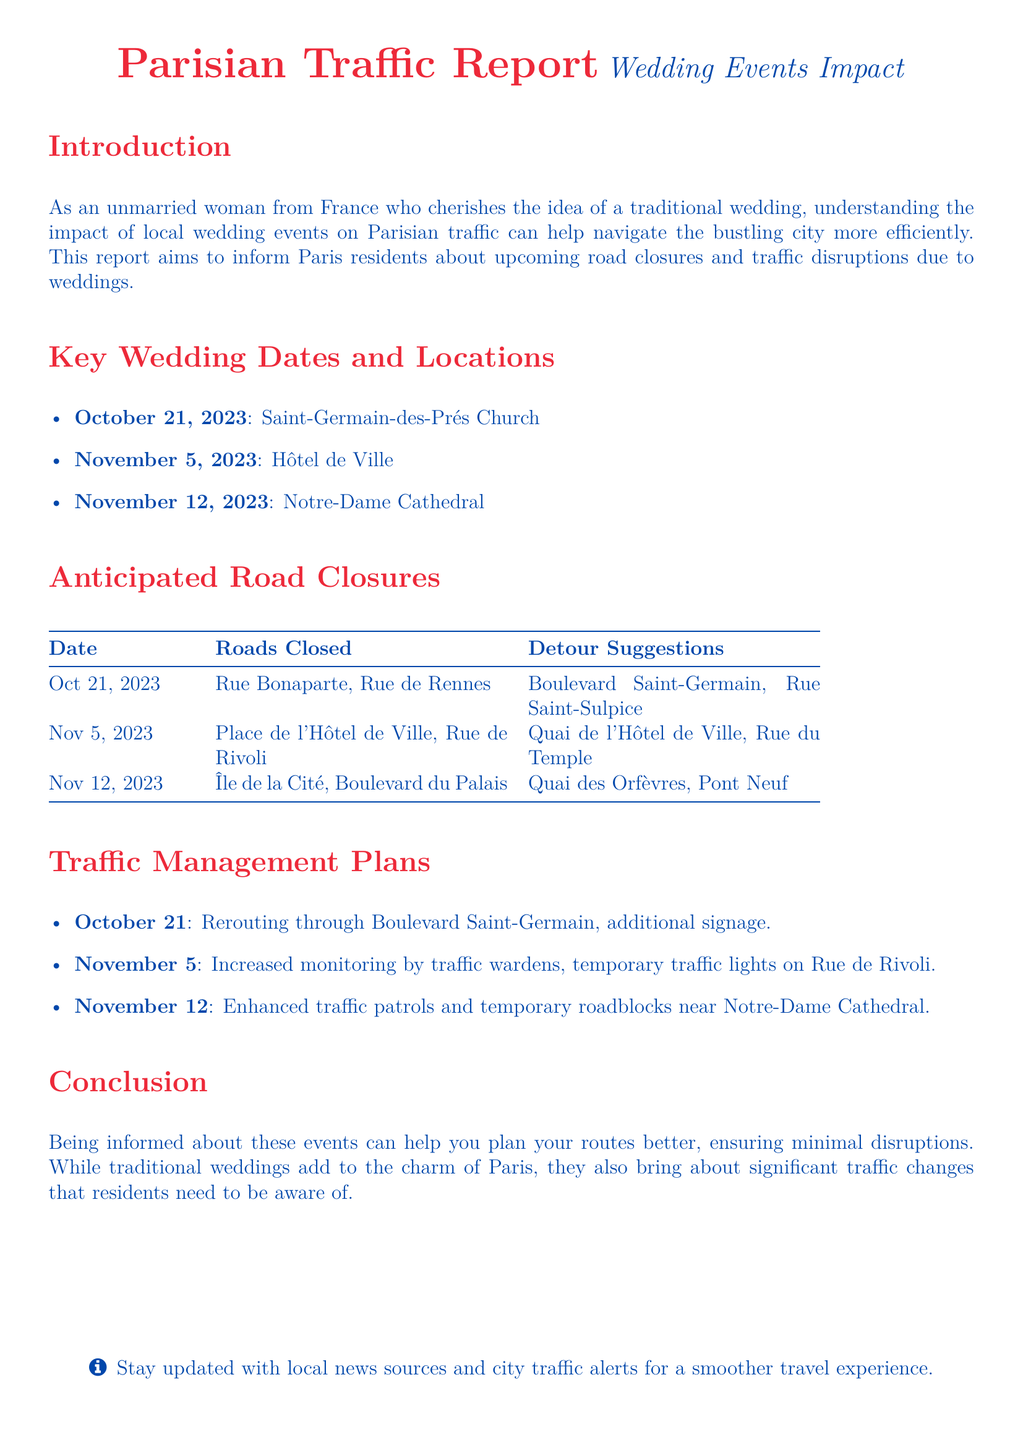what is the first wedding date mentioned? The first wedding date mentioned in the document is October 21, 2023.
Answer: October 21, 2023 where is the wedding on November 5, 2023, taking place? The wedding on November 5, 2023, is taking place at Hôtel de Ville.
Answer: Hôtel de Ville which road will be closed on October 21, 2023? The roads that will be closed on October 21, 2023, include Rue Bonaparte and Rue de Rennes.
Answer: Rue Bonaparte, Rue de Rennes what is the detour suggestion for November 12, 2023? The detour suggestion for November 12, 2023, is Quai des Orfèvres and Pont Neuf.
Answer: Quai des Orfèvres, Pont Neuf how many key wedding dates are listed? There are three key wedding dates listed in the document.
Answer: 3 what traffic management action is taken on November 5? On November 5, the action taken includes increased monitoring by traffic wardens and temporary traffic lights on Rue de Rivoli.
Answer: Increased monitoring, temporary traffic lights which location is mentioned for road closures on the wedding date of November 12? The location mentioned for road closures on November 12 is Île de la Cité.
Answer: Île de la Cité what type of document is this? This document is a traffic report.
Answer: Traffic report what color is used for the section titles in the document? The section titles in the document are colored in Paris red.
Answer: Paris red 